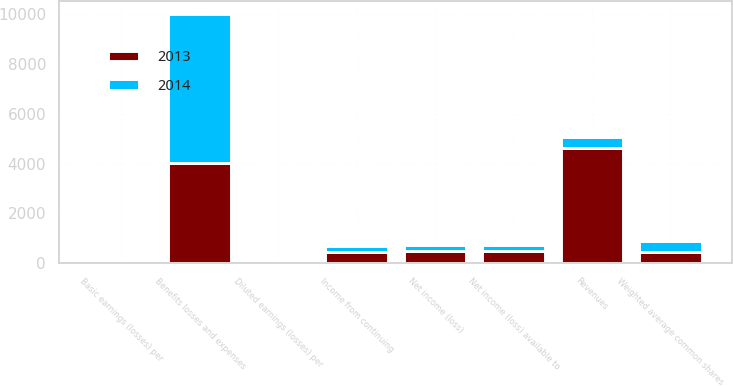Convert chart. <chart><loc_0><loc_0><loc_500><loc_500><stacked_bar_chart><ecel><fcel>Revenues<fcel>Benefits losses and expenses<fcel>Income from continuing<fcel>Net income (loss)<fcel>Net income (loss) available to<fcel>Basic earnings (losses) per<fcel>Diluted earnings (losses) per<fcel>Weighted average common shares<nl><fcel>2013<fcel>4612<fcel>4003<fcel>466<fcel>495<fcel>495<fcel>1.1<fcel>1.03<fcel>449.8<nl><fcel>2014<fcel>436.3<fcel>5994<fcel>243<fcel>241<fcel>251<fcel>0.58<fcel>0.49<fcel>436.3<nl></chart> 